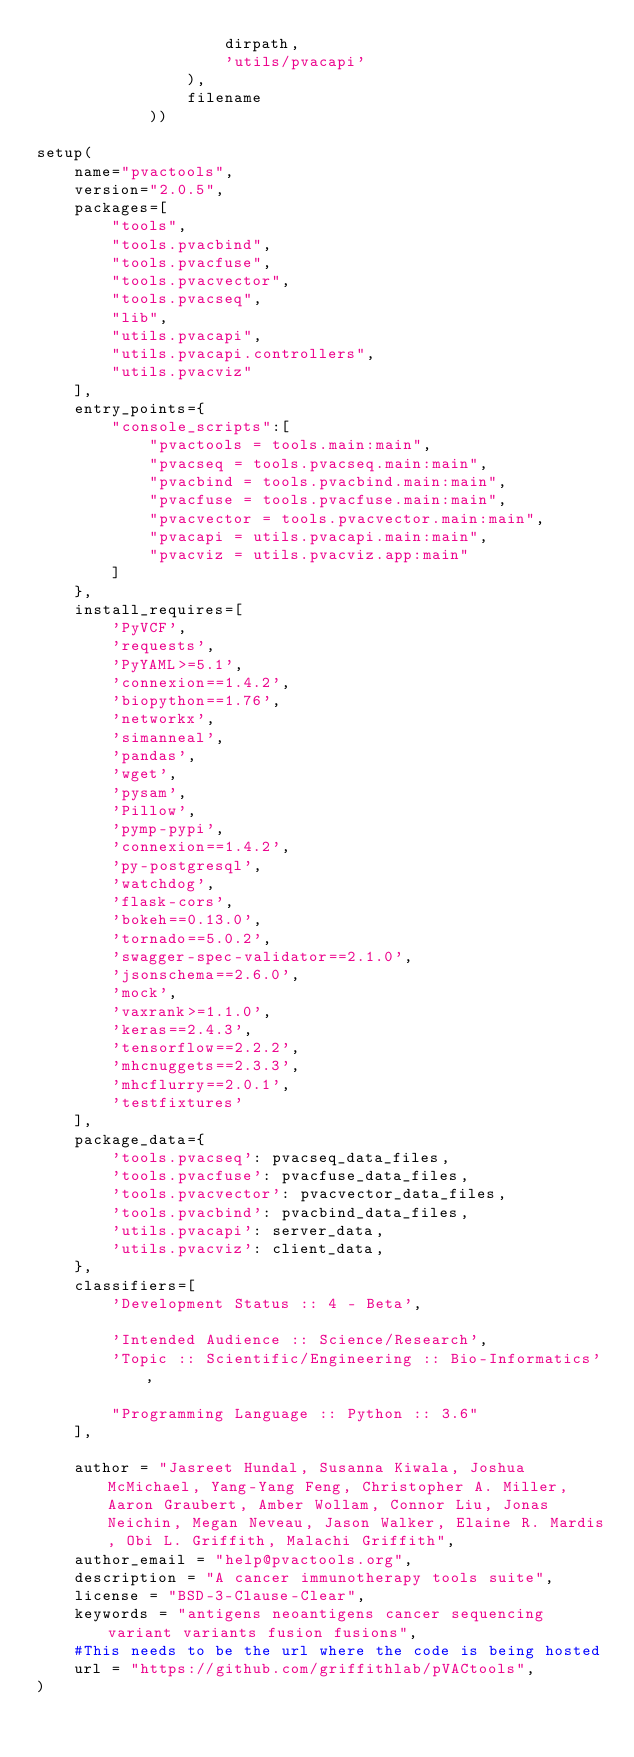Convert code to text. <code><loc_0><loc_0><loc_500><loc_500><_Python_>                    dirpath,
                    'utils/pvacapi'
                ),
                filename
            ))

setup(
    name="pvactools",
    version="2.0.5",
    packages=[
        "tools",
        "tools.pvacbind",
        "tools.pvacfuse",
        "tools.pvacvector",
        "tools.pvacseq",
        "lib",
        "utils.pvacapi",
        "utils.pvacapi.controllers",
        "utils.pvacviz"
    ],
    entry_points={
        "console_scripts":[
            "pvactools = tools.main:main",
            "pvacseq = tools.pvacseq.main:main",
            "pvacbind = tools.pvacbind.main:main",
            "pvacfuse = tools.pvacfuse.main:main",
            "pvacvector = tools.pvacvector.main:main",
            "pvacapi = utils.pvacapi.main:main",
            "pvacviz = utils.pvacviz.app:main"
        ]
    },
    install_requires=[
        'PyVCF',
        'requests',
        'PyYAML>=5.1',
        'connexion==1.4.2',
        'biopython==1.76',
        'networkx',
        'simanneal',
        'pandas',
        'wget',
        'pysam',
        'Pillow',
        'pymp-pypi',
        'connexion==1.4.2',
        'py-postgresql',
        'watchdog',
        'flask-cors',
        'bokeh==0.13.0',
        'tornado==5.0.2',
        'swagger-spec-validator==2.1.0',
        'jsonschema==2.6.0',
        'mock',
        'vaxrank>=1.1.0',
        'keras==2.4.3',
        'tensorflow==2.2.2',
        'mhcnuggets==2.3.3',
        'mhcflurry==2.0.1',
        'testfixtures'
    ],
    package_data={
        'tools.pvacseq': pvacseq_data_files,
        'tools.pvacfuse': pvacfuse_data_files,
        'tools.pvacvector': pvacvector_data_files,
        'tools.pvacbind': pvacbind_data_files,
        'utils.pvacapi': server_data,
        'utils.pvacviz': client_data,
    },
    classifiers=[
        'Development Status :: 4 - Beta',

        'Intended Audience :: Science/Research',
        'Topic :: Scientific/Engineering :: Bio-Informatics',

        "Programming Language :: Python :: 3.6"
    ],

    author = "Jasreet Hundal, Susanna Kiwala, Joshua McMichael, Yang-Yang Feng, Christopher A. Miller, Aaron Graubert, Amber Wollam, Connor Liu, Jonas Neichin, Megan Neveau, Jason Walker, Elaine R. Mardis, Obi L. Griffith, Malachi Griffith",
    author_email = "help@pvactools.org",
    description = "A cancer immunotherapy tools suite",
    license = "BSD-3-Clause-Clear",
    keywords = "antigens neoantigens cancer sequencing variant variants fusion fusions",
    #This needs to be the url where the code is being hosted
    url = "https://github.com/griffithlab/pVACtools",
)
</code> 